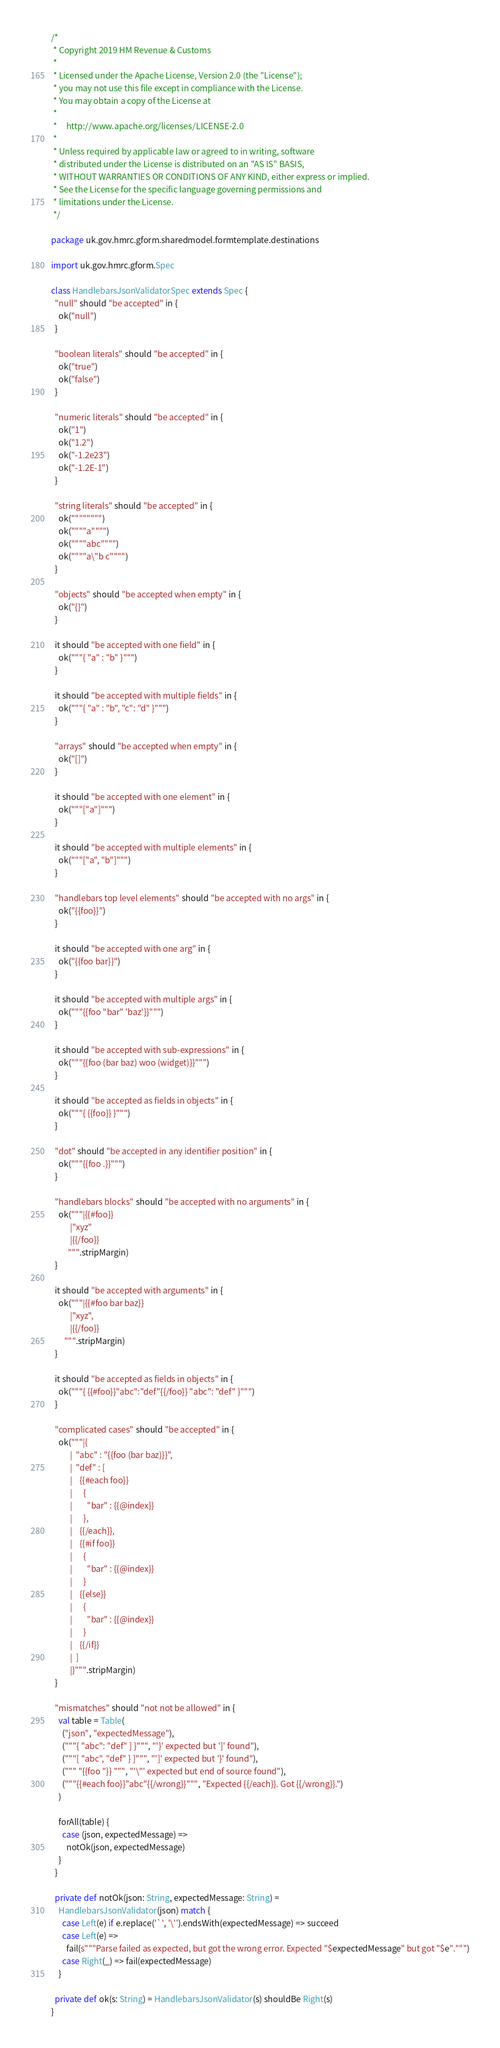<code> <loc_0><loc_0><loc_500><loc_500><_Scala_>/*
 * Copyright 2019 HM Revenue & Customs
 *
 * Licensed under the Apache License, Version 2.0 (the "License");
 * you may not use this file except in compliance with the License.
 * You may obtain a copy of the License at
 *
 *     http://www.apache.org/licenses/LICENSE-2.0
 *
 * Unless required by applicable law or agreed to in writing, software
 * distributed under the License is distributed on an "AS IS" BASIS,
 * WITHOUT WARRANTIES OR CONDITIONS OF ANY KIND, either express or implied.
 * See the License for the specific language governing permissions and
 * limitations under the License.
 */

package uk.gov.hmrc.gform.sharedmodel.formtemplate.destinations

import uk.gov.hmrc.gform.Spec

class HandlebarsJsonValidatorSpec extends Spec {
  "null" should "be accepted" in {
    ok("null")
  }

  "boolean literals" should "be accepted" in {
    ok("true")
    ok("false")
  }

  "numeric literals" should "be accepted" in {
    ok("1")
    ok("1.2")
    ok("-1.2e23")
    ok("-1.2E-1")
  }

  "string literals" should "be accepted" in {
    ok("""""""")
    ok(""""a"""")
    ok(""""abc"""")
    ok(""""a\"b c"""")
  }

  "objects" should "be accepted when empty" in {
    ok("{}")
  }

  it should "be accepted with one field" in {
    ok("""{ "a" : "b" }""")
  }

  it should "be accepted with multiple fields" in {
    ok("""{ "a" : "b", "c": "d" }""")
  }

  "arrays" should "be accepted when empty" in {
    ok("[]")
  }

  it should "be accepted with one element" in {
    ok("""["a"]""")
  }

  it should "be accepted with multiple elements" in {
    ok("""["a", "b"]""")
  }

  "handlebars top level elements" should "be accepted with no args" in {
    ok("{{foo}}")
  }

  it should "be accepted with one arg" in {
    ok("{{foo bar}}")
  }

  it should "be accepted with multiple args" in {
    ok("""{{foo "bar" 'baz'}}""")
  }

  it should "be accepted with sub-expressions" in {
    ok("""{{foo (bar baz) woo (widget)}}""")
  }

  it should "be accepted as fields in objects" in {
    ok("""{ {{foo}} }""")
  }

  "dot" should "be accepted in any identifier position" in {
    ok("""{{foo .}}""")
  }

  "handlebars blocks" should "be accepted with no arguments" in {
    ok("""|{{#foo}}
          |"xyz"
          |{{/foo}}
         """.stripMargin)
  }

  it should "be accepted with arguments" in {
    ok("""|{{#foo bar baz}}
          |"xyz",
          |{{/foo}}
       """.stripMargin)
  }

  it should "be accepted as fields in objects" in {
    ok("""{ {{#foo}}"abc":"def"{{/foo}} "abc": "def" }""")
  }

  "complicated cases" should "be accepted" in {
    ok("""|{
          |  "abc" : "{{foo (bar baz)}}",
          |  "def" : [
          |    {{#each foo}}
          |      {
          |        "bar" : {{@index}}
          |      },
          |    {{/each}},
          |    {{#if foo}}
          |      {
          |        "bar" : {{@index}}
          |      }
          |    {{else}}
          |      {
          |        "bar" : {{@index}}
          |      }
          |    {{/if}}
          |  ]
          |}""".stripMargin)
  }

  "mismatches" should "not not be allowed" in {
    val table = Table(
      ("json", "expectedMessage"),
      ("""{ "abc": "def" ] }""", "'}' expected but ']' found"),
      ("""[ "abc", "def" } ]""", "']' expected but '}' found"),
      (""" "{{foo "}} """, "'\"' expected but end of source found"),
      ("""{{#each foo}}"abc"{{/wrong}}""", "Expected {{/each}}. Got {{/wrong}}.")
    )

    forAll(table) {
      case (json, expectedMessage) =>
        notOk(json, expectedMessage)
    }
  }

  private def notOk(json: String, expectedMessage: String) =
    HandlebarsJsonValidator(json) match {
      case Left(e) if e.replace('`', '\'').endsWith(expectedMessage) => succeed
      case Left(e) =>
        fail(s"""Parse failed as expected, but got the wrong error. Expected "$expectedMessage" but got "$e".""")
      case Right(_) => fail(expectedMessage)
    }

  private def ok(s: String) = HandlebarsJsonValidator(s) shouldBe Right(s)
}
</code> 